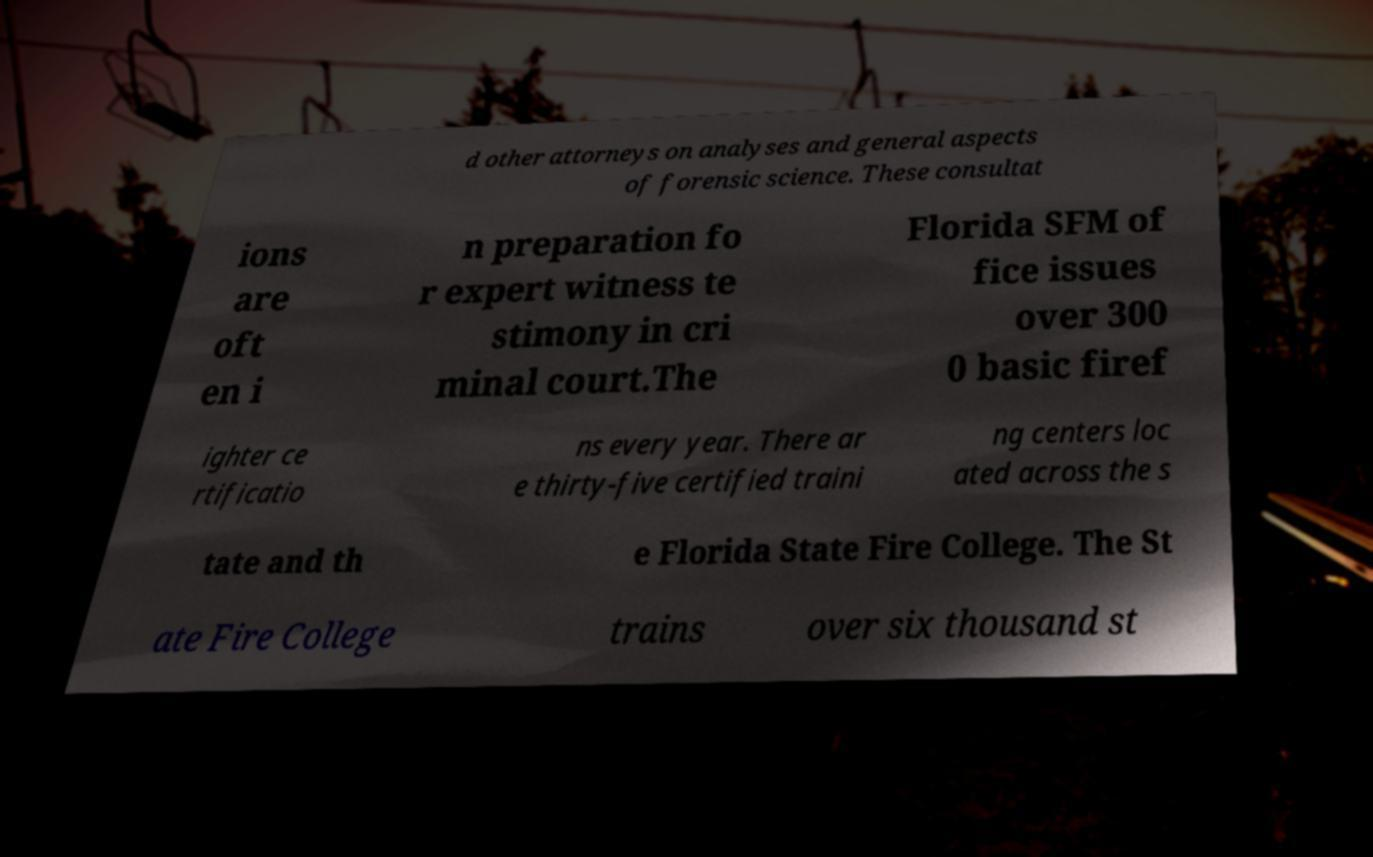Could you extract and type out the text from this image? d other attorneys on analyses and general aspects of forensic science. These consultat ions are oft en i n preparation fo r expert witness te stimony in cri minal court.The Florida SFM of fice issues over 300 0 basic firef ighter ce rtificatio ns every year. There ar e thirty-five certified traini ng centers loc ated across the s tate and th e Florida State Fire College. The St ate Fire College trains over six thousand st 